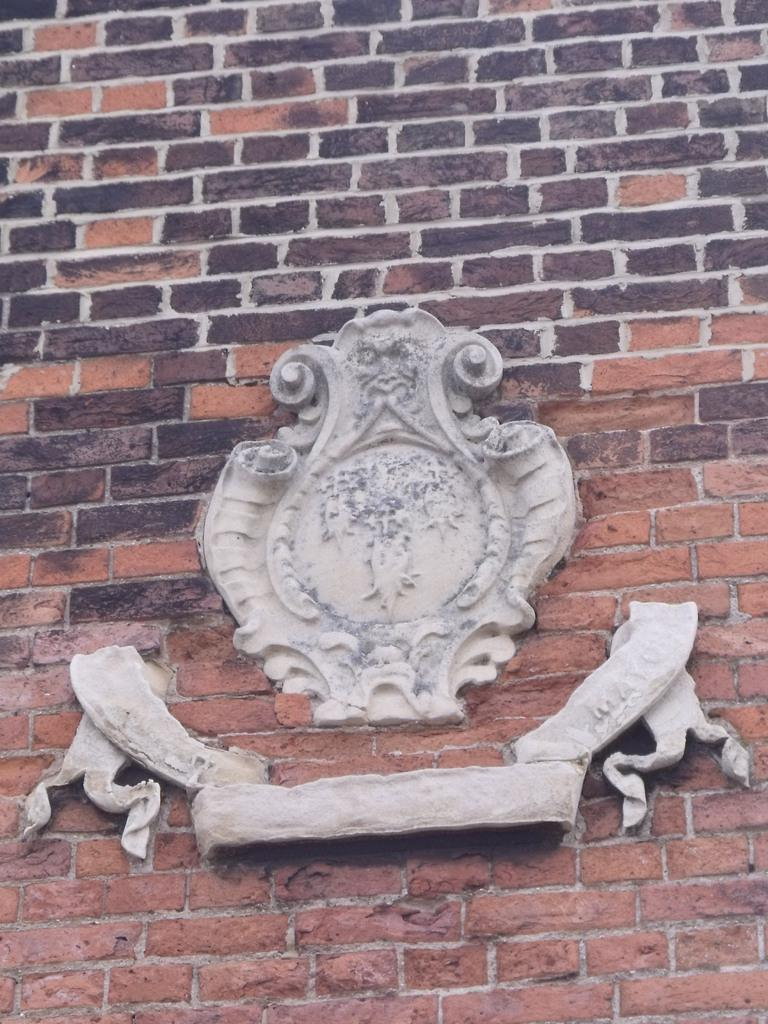What is the main subject in the image? There is a sculpture in the image. Can you describe the setting or background of the sculpture? The sculpture is in front of a brick wall. What type of furniture is visible in the image? There is no furniture present in the image. What is the power source for the sculpture in the image? The sculpture does not require a power source, as it is a static object. What is the heart rate of the sculpture in the image? The sculpture is an inanimate object and does not have a heart rate. 